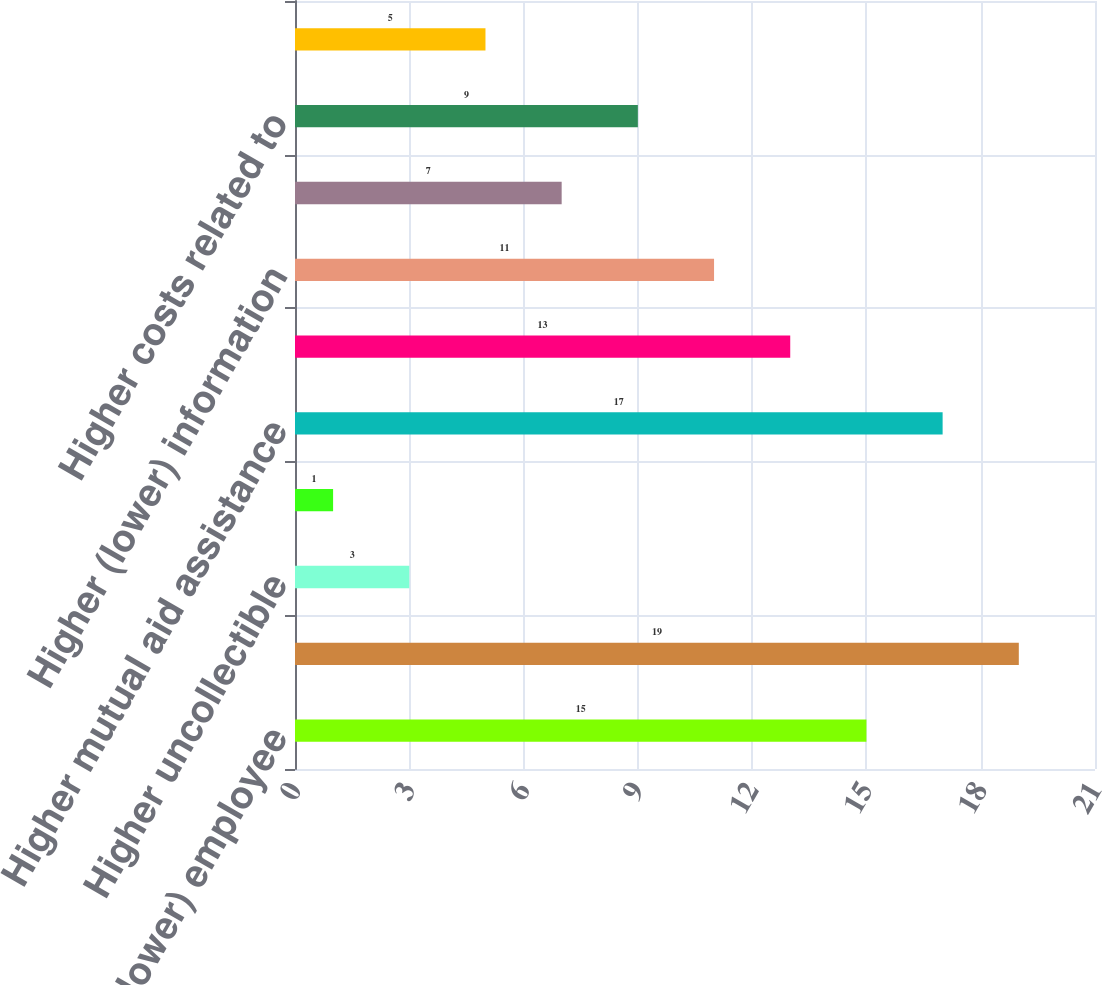Convert chart to OTSL. <chart><loc_0><loc_0><loc_500><loc_500><bar_chart><fcel>Higher (lower) employee<fcel>Higher (lower) nuclear plant<fcel>Higher uncollectible<fcel>Higher donations to energy<fcel>Higher mutual aid assistance<fcel>Higher electric service<fcel>Higher (lower) information<fcel>Higher (lower) plant-related<fcel>Higher costs related to<fcel>Other<nl><fcel>15<fcel>19<fcel>3<fcel>1<fcel>17<fcel>13<fcel>11<fcel>7<fcel>9<fcel>5<nl></chart> 